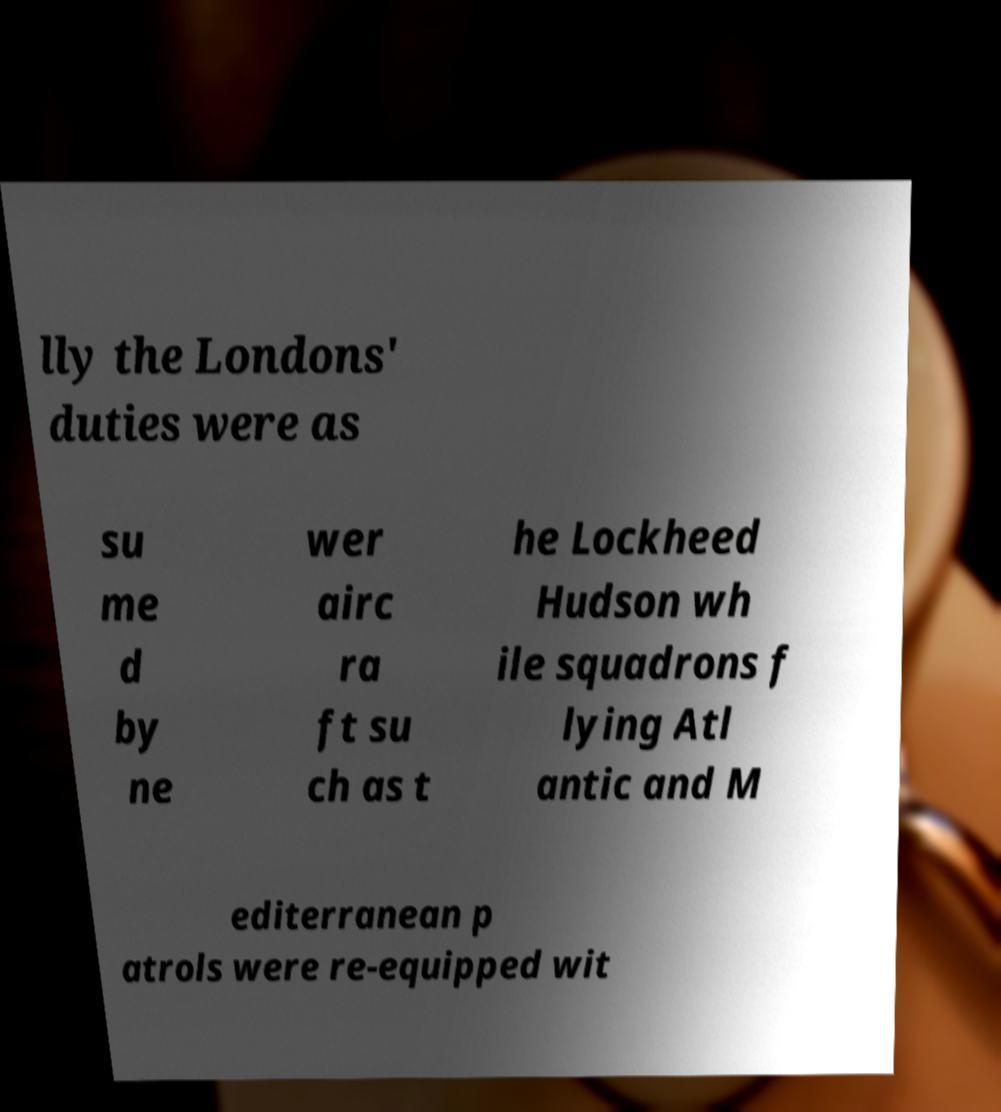Can you read and provide the text displayed in the image?This photo seems to have some interesting text. Can you extract and type it out for me? lly the Londons' duties were as su me d by ne wer airc ra ft su ch as t he Lockheed Hudson wh ile squadrons f lying Atl antic and M editerranean p atrols were re-equipped wit 